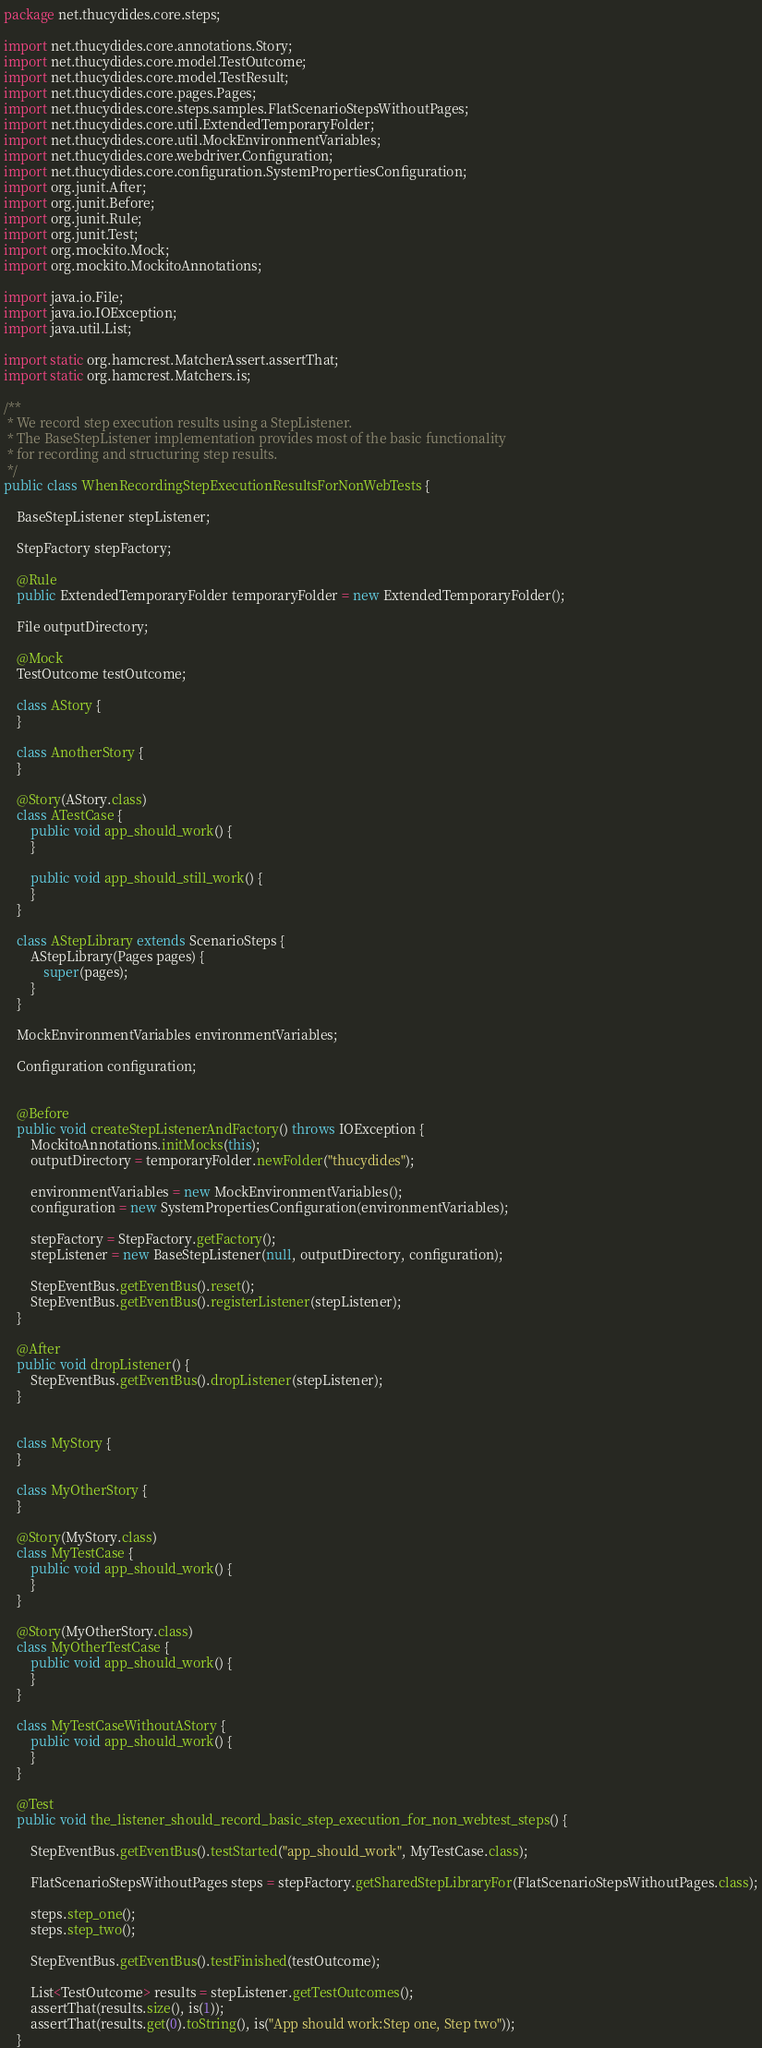<code> <loc_0><loc_0><loc_500><loc_500><_Java_>package net.thucydides.core.steps;

import net.thucydides.core.annotations.Story;
import net.thucydides.core.model.TestOutcome;
import net.thucydides.core.model.TestResult;
import net.thucydides.core.pages.Pages;
import net.thucydides.core.steps.samples.FlatScenarioStepsWithoutPages;
import net.thucydides.core.util.ExtendedTemporaryFolder;
import net.thucydides.core.util.MockEnvironmentVariables;
import net.thucydides.core.webdriver.Configuration;
import net.thucydides.core.configuration.SystemPropertiesConfiguration;
import org.junit.After;
import org.junit.Before;
import org.junit.Rule;
import org.junit.Test;
import org.mockito.Mock;
import org.mockito.MockitoAnnotations;

import java.io.File;
import java.io.IOException;
import java.util.List;

import static org.hamcrest.MatcherAssert.assertThat;
import static org.hamcrest.Matchers.is;

/**
 * We record step execution results using a StepListener.
 * The BaseStepListener implementation provides most of the basic functionality
 * for recording and structuring step results.
 */
public class WhenRecordingStepExecutionResultsForNonWebTests {

    BaseStepListener stepListener;

    StepFactory stepFactory;

    @Rule
    public ExtendedTemporaryFolder temporaryFolder = new ExtendedTemporaryFolder();

    File outputDirectory;

    @Mock
    TestOutcome testOutcome;

    class AStory {
    }

    class AnotherStory {
    }

    @Story(AStory.class)
    class ATestCase {
        public void app_should_work() {
        }

        public void app_should_still_work() {
        }
    }

    class AStepLibrary extends ScenarioSteps {
        AStepLibrary(Pages pages) {
            super(pages);
        }
    }

    MockEnvironmentVariables environmentVariables;

    Configuration configuration;


    @Before
    public void createStepListenerAndFactory() throws IOException {
        MockitoAnnotations.initMocks(this);
        outputDirectory = temporaryFolder.newFolder("thucydides");

        environmentVariables = new MockEnvironmentVariables();
        configuration = new SystemPropertiesConfiguration(environmentVariables);

        stepFactory = StepFactory.getFactory();
        stepListener = new BaseStepListener(null, outputDirectory, configuration);

        StepEventBus.getEventBus().reset();
        StepEventBus.getEventBus().registerListener(stepListener);
    }

    @After
    public void dropListener() {
        StepEventBus.getEventBus().dropListener(stepListener);
    }


    class MyStory {
    }

    class MyOtherStory {
    }

    @Story(MyStory.class)
    class MyTestCase {
        public void app_should_work() {
        }
    }

    @Story(MyOtherStory.class)
    class MyOtherTestCase {
        public void app_should_work() {
        }
    }

    class MyTestCaseWithoutAStory {
        public void app_should_work() {
        }
    }

    @Test
    public void the_listener_should_record_basic_step_execution_for_non_webtest_steps() {

        StepEventBus.getEventBus().testStarted("app_should_work", MyTestCase.class);

        FlatScenarioStepsWithoutPages steps = stepFactory.getSharedStepLibraryFor(FlatScenarioStepsWithoutPages.class);

        steps.step_one();
        steps.step_two();

        StepEventBus.getEventBus().testFinished(testOutcome);

        List<TestOutcome> results = stepListener.getTestOutcomes();
        assertThat(results.size(), is(1));
        assertThat(results.get(0).toString(), is("App should work:Step one, Step two"));
    }

</code> 